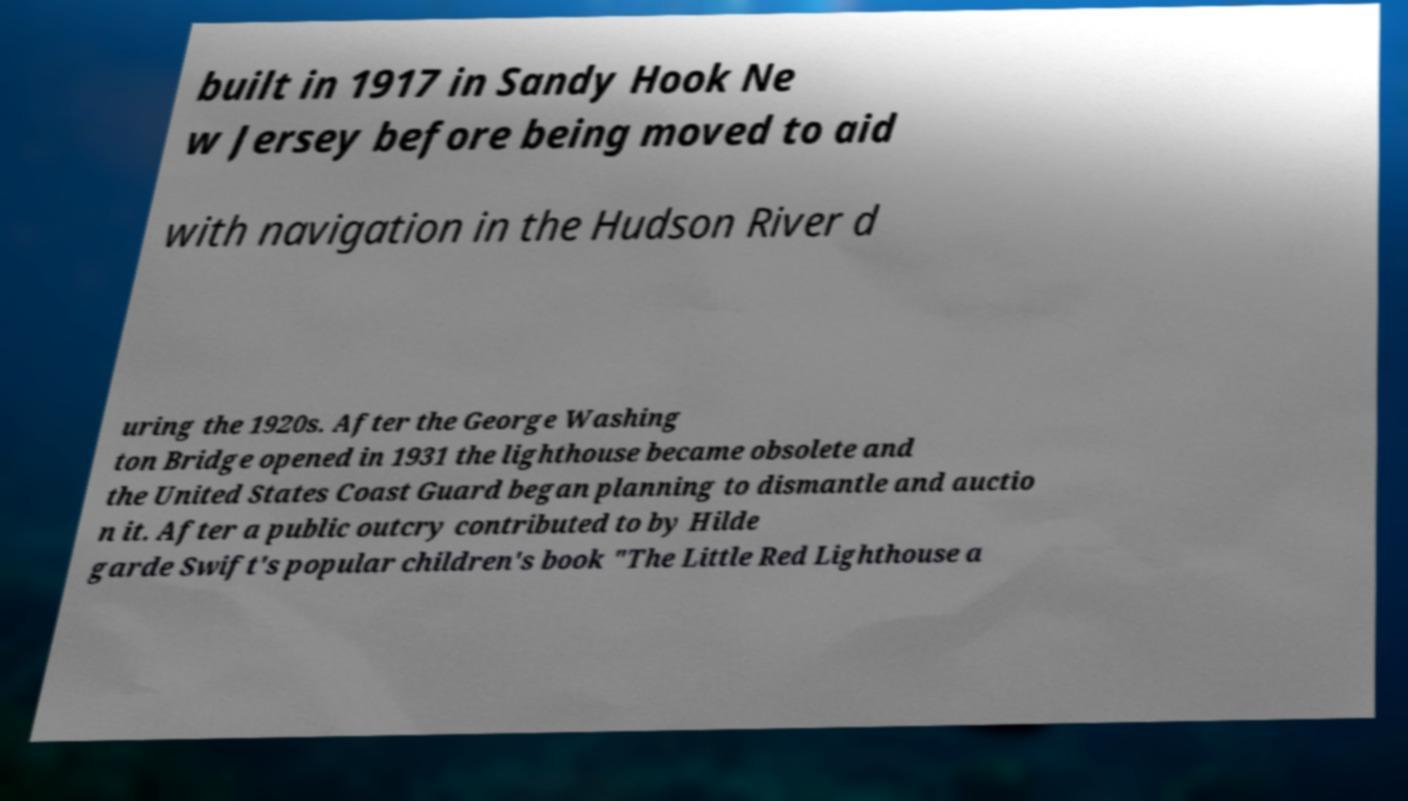I need the written content from this picture converted into text. Can you do that? built in 1917 in Sandy Hook Ne w Jersey before being moved to aid with navigation in the Hudson River d uring the 1920s. After the George Washing ton Bridge opened in 1931 the lighthouse became obsolete and the United States Coast Guard began planning to dismantle and auctio n it. After a public outcry contributed to by Hilde garde Swift's popular children's book "The Little Red Lighthouse a 